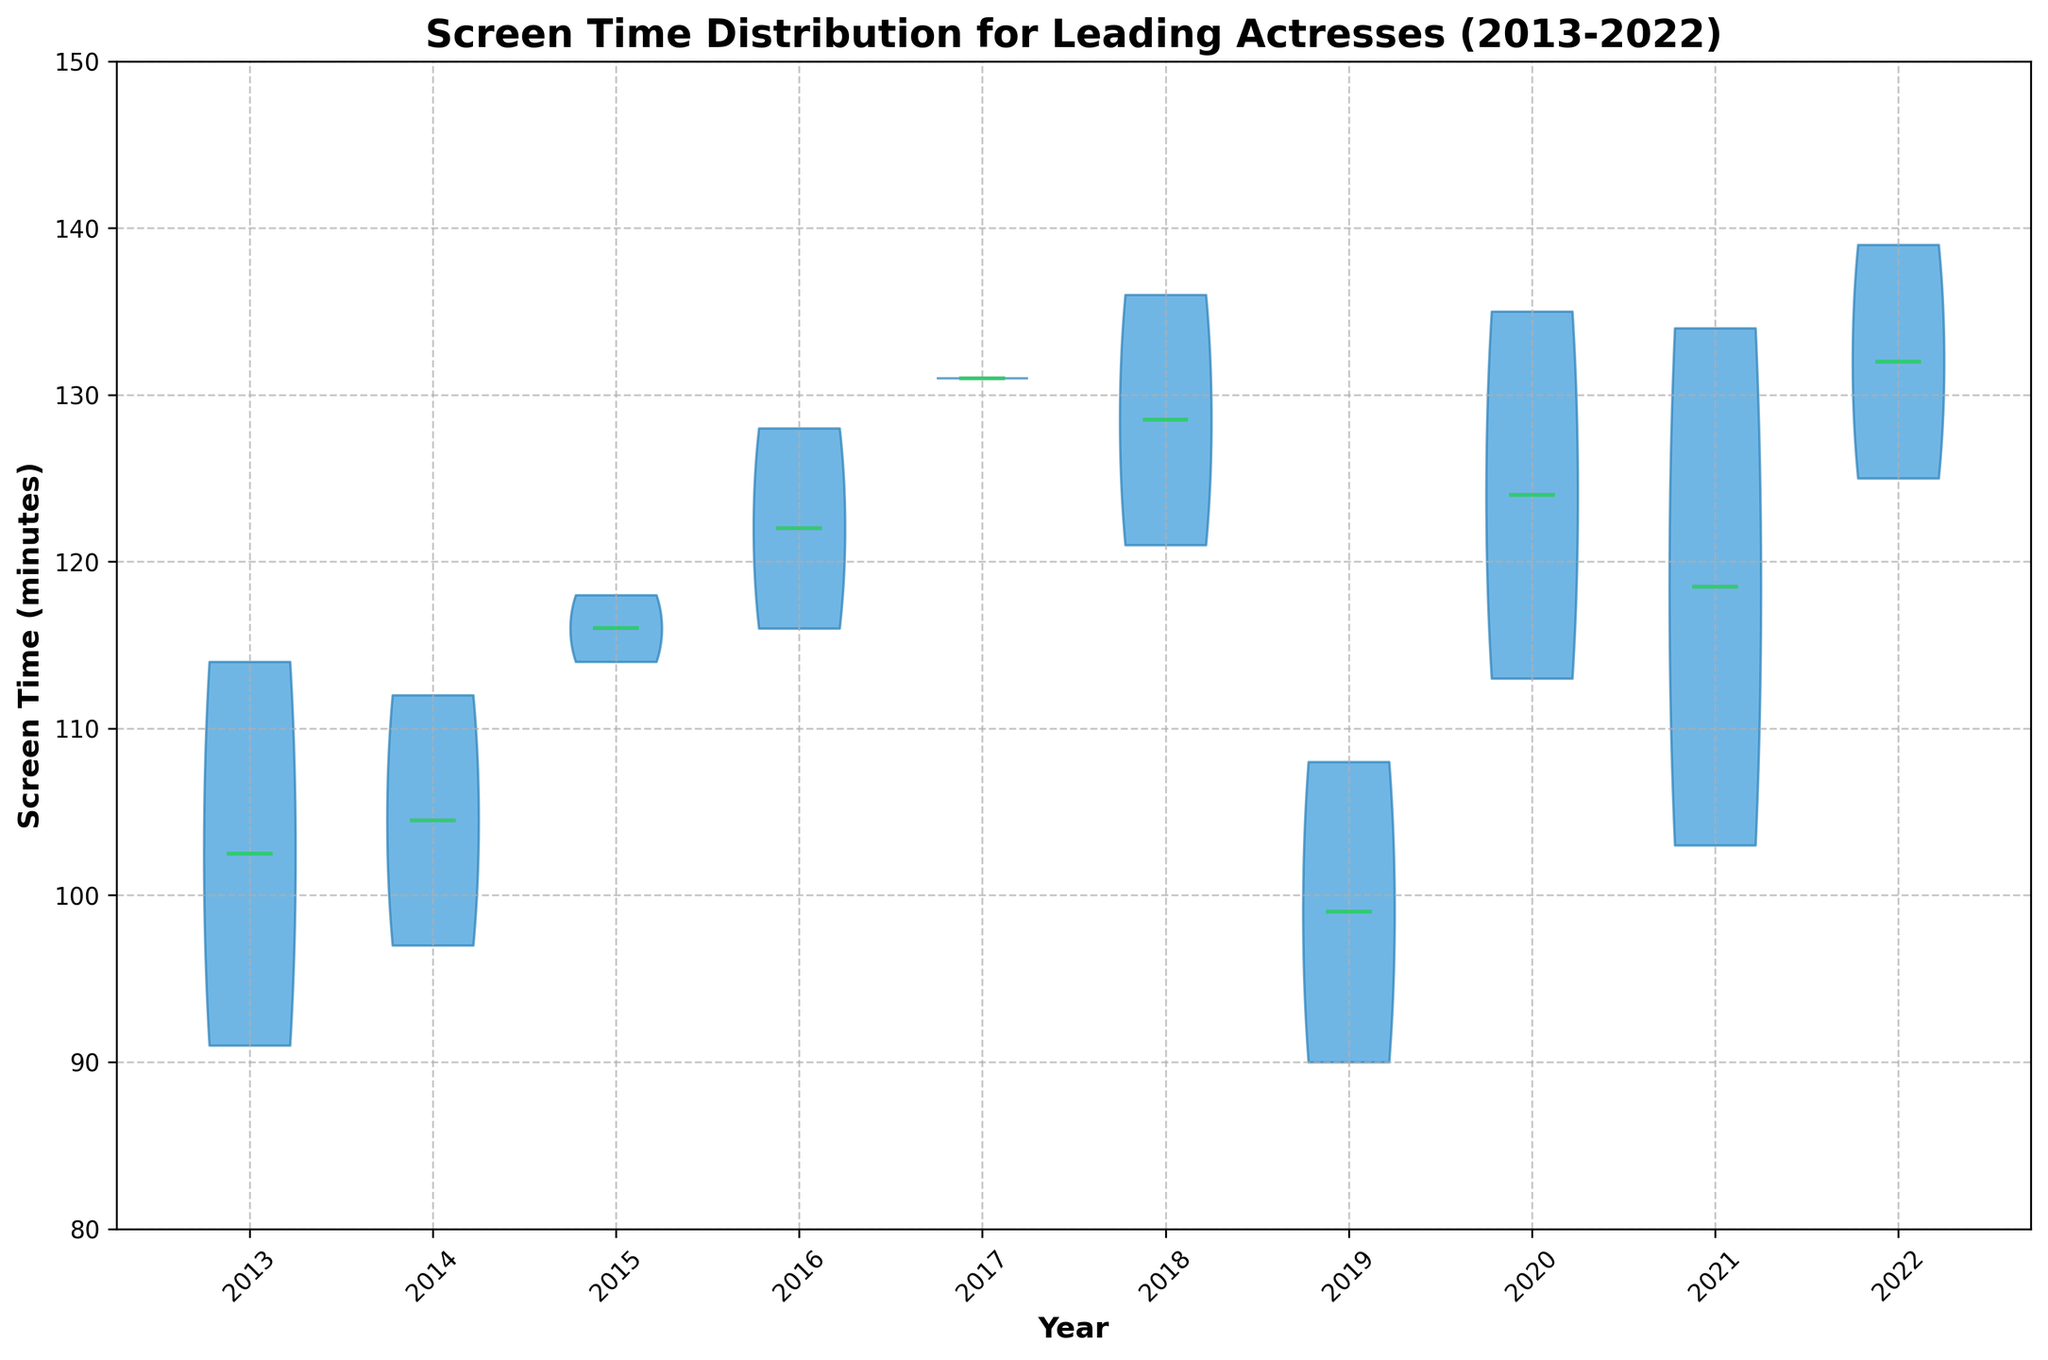What is the title of the plot? The title of the plot is the text displayed at the top of the figure, which gives an overview of what the plot represents.
Answer: Screen Time Distribution for Leading Actresses (2013-2022) What is the median screen time for leading actresses in 2016? To find the median screen time for 2016, observe the horizontal line (green) within the violin plot for that year. The median is visually represented by the green line.
Answer: About 116 minutes Which year has the highest median screen time for leading actresses? Compare all the green horizontal lines (medians) across the violin plots for each year to identify the highest one.
Answer: 2022 Between 2018 and 2021, which year had the lower mean screen time for leading actresses? Compare the red circle markers (means) within the violin plots for the years 2018 and 2021. The year with the lower red circle marker is the answer.
Answer: 2018 What color represents the mean screen time on the violin chart? By observing the distinguishing colors, the mean screen time is represented by a specific color marker (red).
Answer: Red How many years are represented in the plot? Count the number of separate violin plots or distinct tick marks along the x-axis; each tick represents a different year.
Answer: 10 What is the screen time range (minimum to maximum) observed in the violin chart between 2013 and 2022? The screen time range can be determined by finding the lower and upper extremes of the violin plots over all the years. Check the vertical span of the plots from the lowest to the highest points.
Answer: About 80 to 150 minutes Which year shows the greatest variability in screen time for leading actresses, and how can you tell? Variability can be observed by the width of the violin plots; a wider plot indicates more variability. Compare the widths of the plots and identify the widest one.
Answer: 2018 (based on the width of the plot) Is there a noticeable trend in the median screen time for leading actresses over the last decade? To identify a trend, observe the progression of the green horizontal lines (medians) from 2013 to 2022 and see if they increase, decrease, or remain stable over time.
Answer: Slight increase 